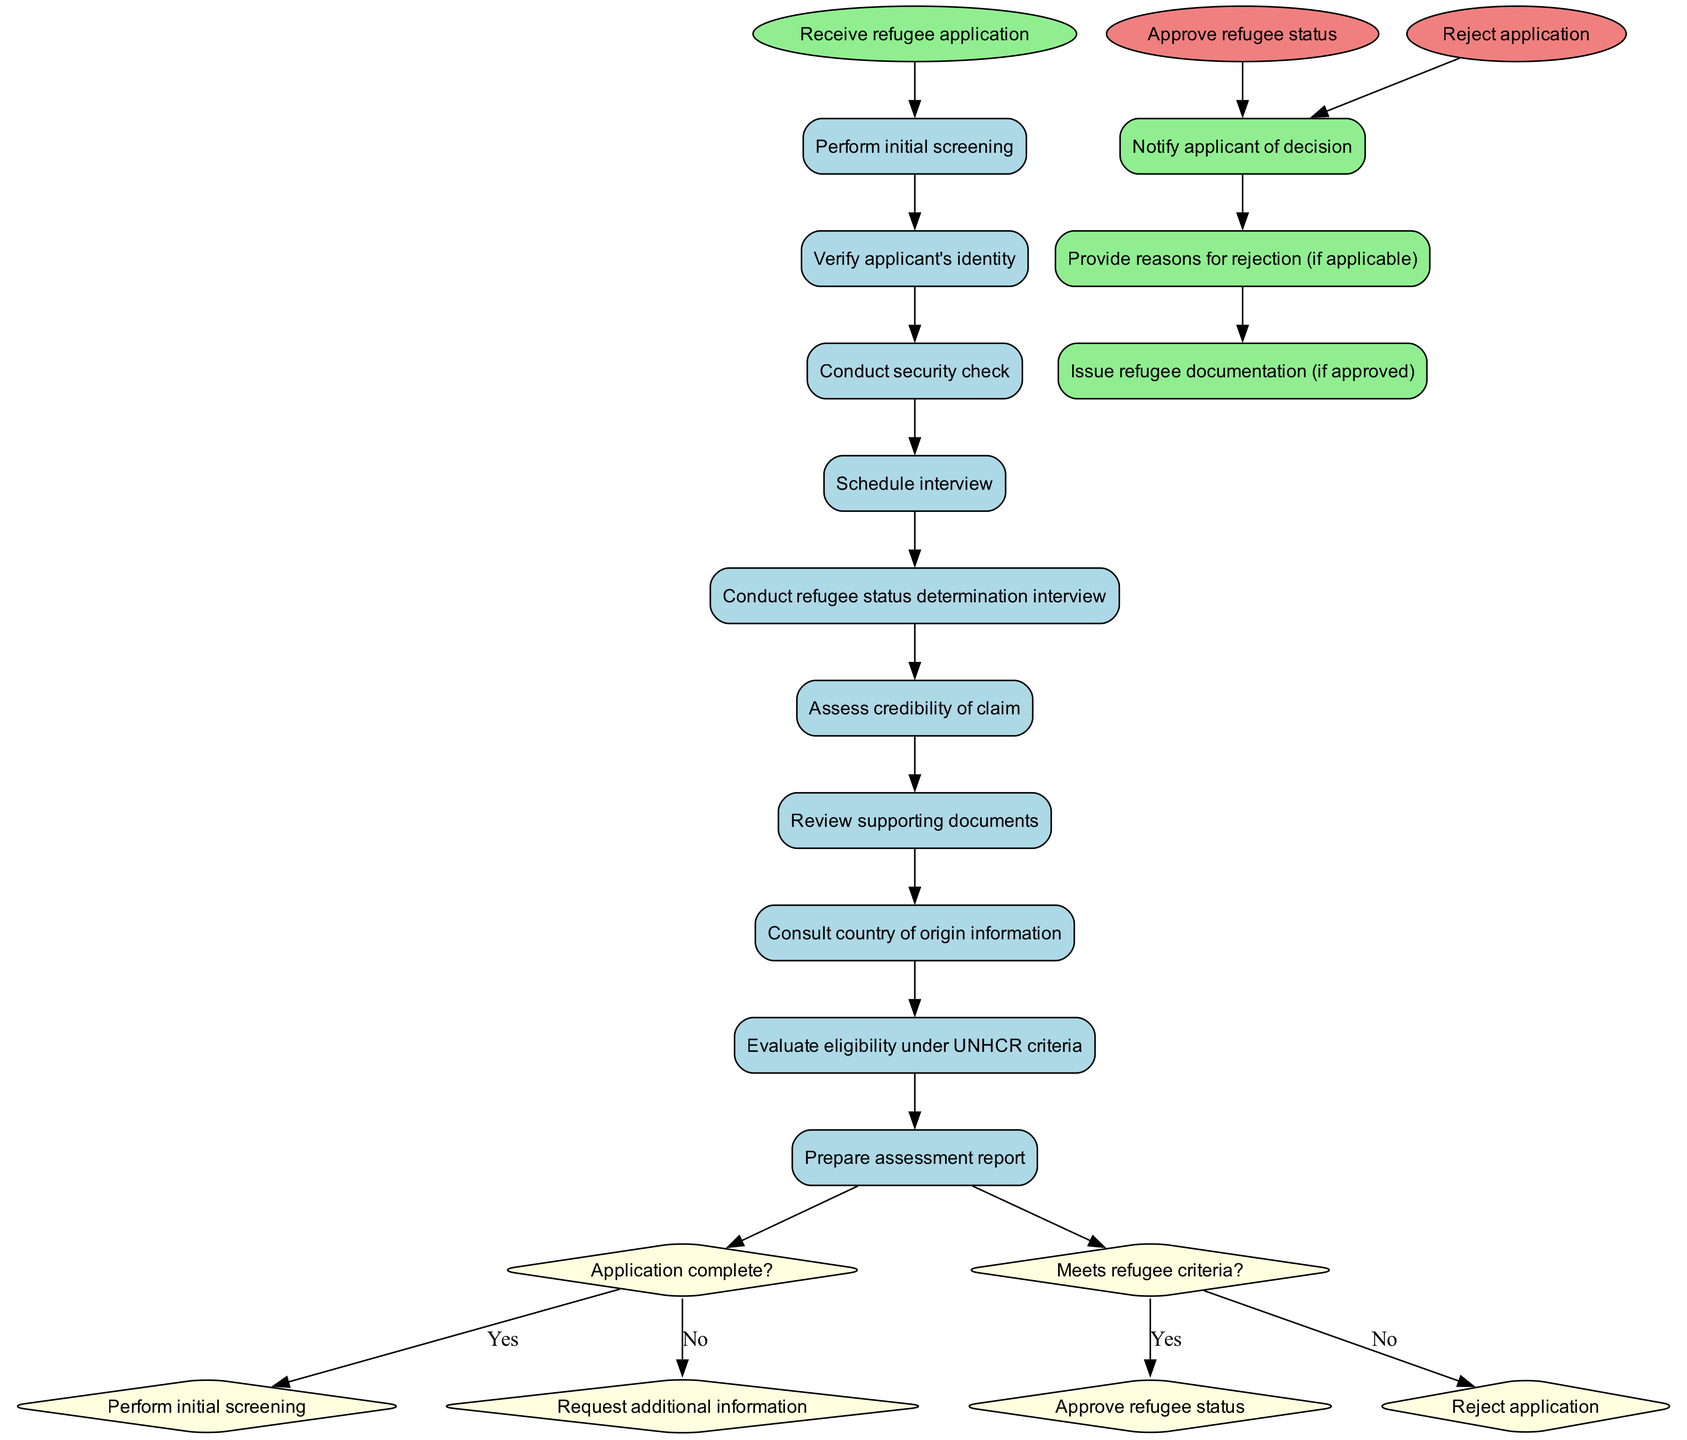What is the starting point of the refugee application review process? The starting point is the "Receive refugee application" node. This is the first node depicted in the diagram from which the process begins.
Answer: Receive refugee application How many activities are involved in the review process? There are 10 listed activities in the diagram that are part of the review process. Each activity can be traced sequentially from the starting node to the decision nodes.
Answer: 10 What is the outcome if the application is complete? If the application is complete, it leads to the next activity, which is "Perform initial screening." This is shown as a direct progression from the decision node labeled "Application complete?" to the activity node.
Answer: Perform initial screening What happens when the application does not meet the refugee criteria? When the application does not meet the refugee criteria, the process leads to the "Reject application" end node. This is reflected in the flow from the decision node that checks eligibility under UNHCR criteria.
Answer: Reject application Which additional action follows a decision to approve refugee status? After the approval of refugee status, the subsequent action is "Issue refugee documentation." This follows the approval node and is part of the additional actions specified for successful applications.
Answer: Issue refugee documentation What connects "Conduct security check" to the next step? The connection from "Conduct security check" to the next step is made by a directed edge leading to "Schedule interview." This shows the flow of the process from one activity to the next.
Answer: Schedule interview What does the decision node labeled "Application complete?" determine? The decision node "Application complete?" determines whether the application is complete or if additional information is needed. It represents a bifurcation point in the process flow based on the completeness of the application.
Answer: Completeness of the application How many end nodes are represented in the diagram? There are 2 end nodes represented, which are "Approve refugee status" and "Reject application." Each of these indicates a final outcome of the review process.
Answer: 2 What is the action taken if the application is rejected? If the application is rejected, the action taken is to "Provide reasons for rejection (if applicable)." This links to the process of notifying the applicant of the decision, showing transparency in the results.
Answer: Provide reasons for rejection (if applicable) 